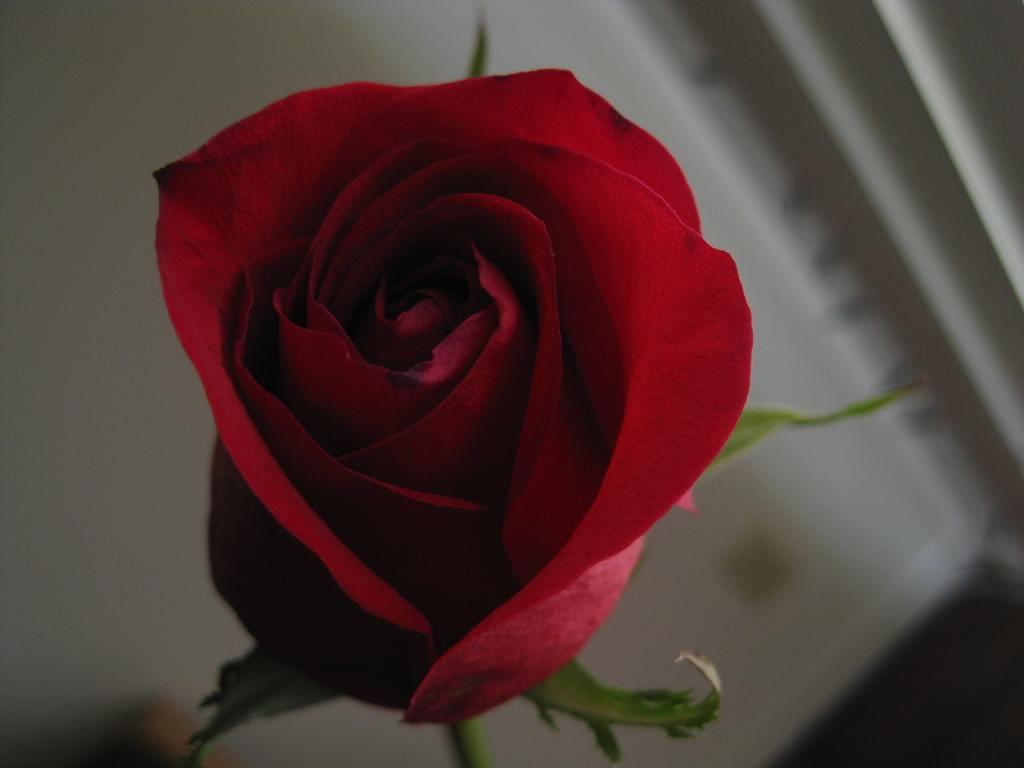What type of flower is in the image? There is a red flower in the image. Can you describe the background of the image? The background of the image is blurred. Is the kitty performing on stage in the image? There is no kitty or stage present in the image. 